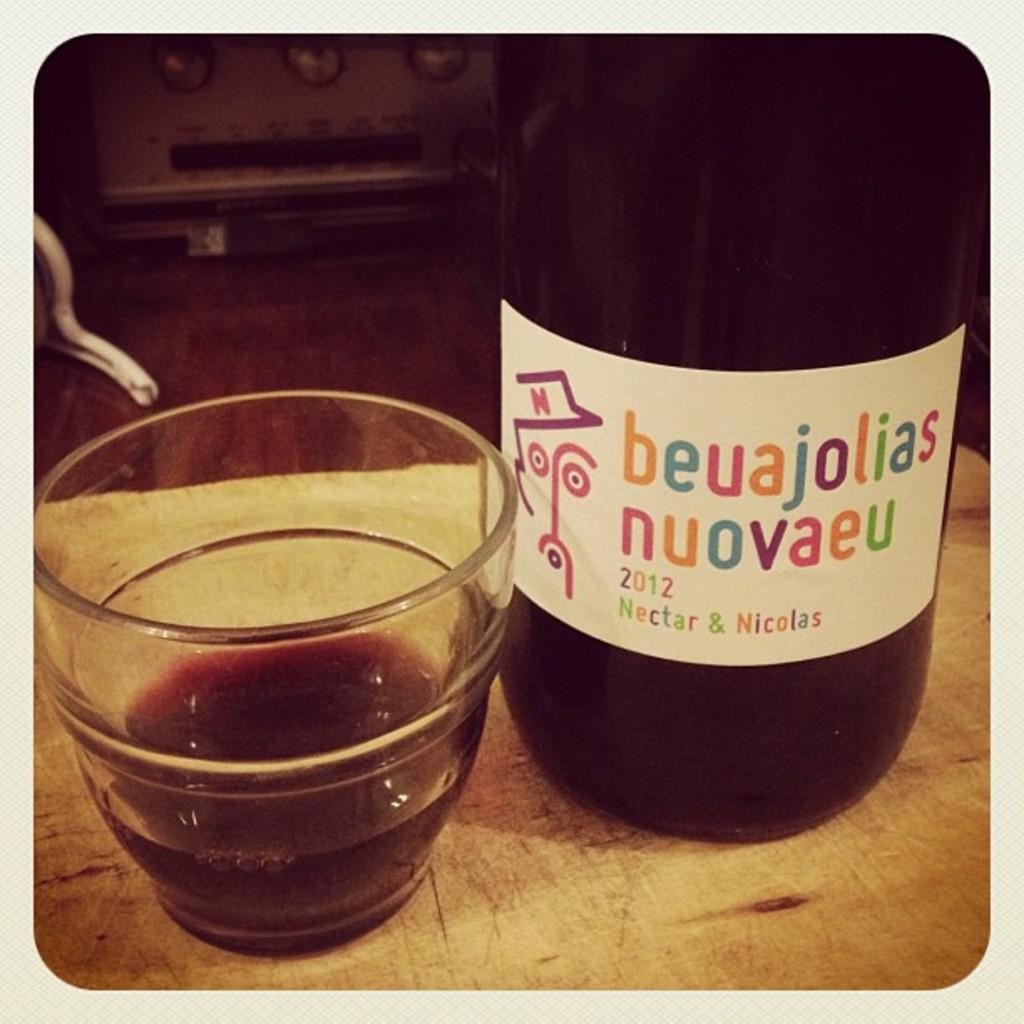What year was the nectar made in ?
Your response must be concise. 2012. What is the name of this beverage?
Provide a succinct answer. Beuajolias nuovaeu. 